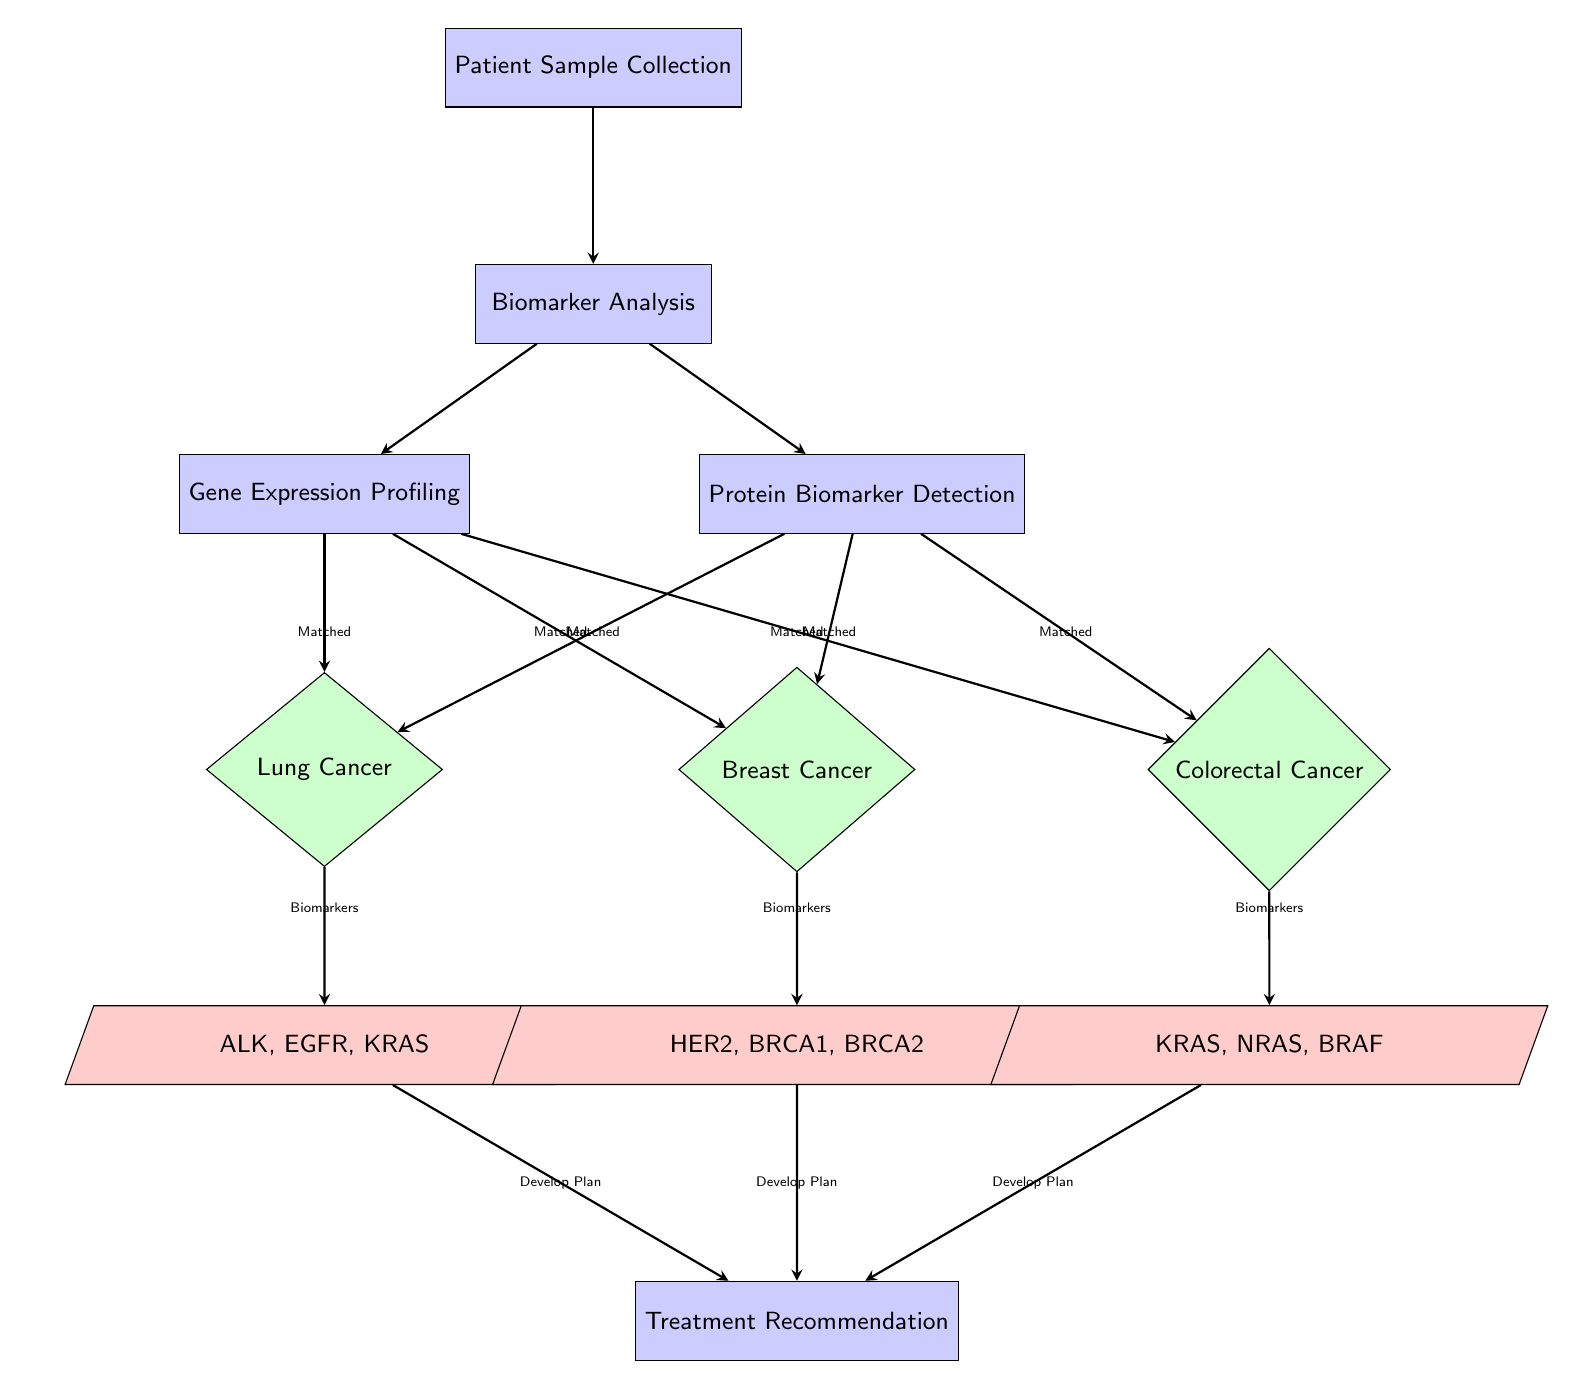What is the first step in the flowchart? The first step in the flowchart is indicated as "Patient Sample Collection," which is the initial process that begins the diagnostic pathway.
Answer: Patient Sample Collection How many types of cancer are identified in the flowchart? The flowchart identifies three types of cancer: Lung Cancer, Breast Cancer, and Colorectal Cancer, which are represented as decision nodes branching from the biomarker analysis.
Answer: Three Which biomarkers are associated with Breast Cancer? The flowchart specifies that the biomarkers related to Breast Cancer are HER2, BRCA1, and BRCA2, which are displayed as data nodes below the Breast Cancer decision.
Answer: HER2, BRCA1, BRCA2 What two processes follow the Biomarker Analysis step? Following the "Biomarker Analysis" step in the flowchart, the two processes are "Gene Expression Profiling" and "Protein Biomarker Detection," both of which branch out from the biomarker analysis node.
Answer: Gene Expression Profiling and Protein Biomarker Detection If a patient has Lung Cancer, which biomarkers are expected to be analyzed? According to the flowchart, if a patient is diagnosed with Lung Cancer, the specific biomarkers that will be investigated are ALK, EGFR, and KRAS, as indicated in the data node for Lung Cancer.
Answer: ALK, EGFR, KRAS Which cancer type has its biomarkers listed directly under it in the flowchart? The flowchart shows that Breast Cancer has its associated biomarkers listed directly underneath it in the diagram, specifically HER2, BRCA1, and BRCA2.
Answer: Breast Cancer What is the final step after identifying the biomarkers for each cancer type? The final step in the flowchart after identifying biomarkers for each cancer type is "Treatment Recommendation," which is the concluding process that follows the analysis of biomarkers.
Answer: Treatment Recommendation Which decision node has the most branching paths leading to it? The decision node for lung cancer has multiple paths leading to it, with branches coming from both the gene profiling and protein detection processes, indicating it's analyzed based on different types of biomarker analysis.
Answer: Lung Cancer What do all the treatment pathways have in common in this flowchart? All treatment pathways in the flowchart involve the development of a plan incorporating the identified biomarkers for each type of cancer, as indicated by the common final process leading from the biomarker nodes.
Answer: Develop Plan 